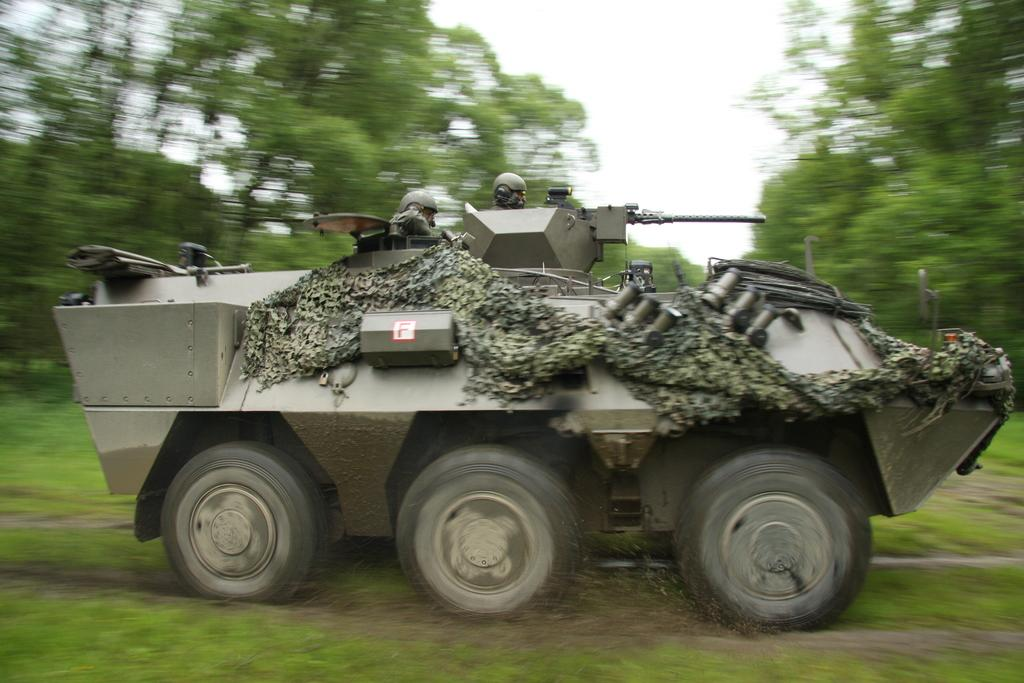What is the main subject of the image? There is a vehicle in the image. Who is inside the vehicle? There are people wearing helmets inside the vehicle. What type of environment is visible in the image? There is grass, trees, and the sky visible in the image. What type of tax is being discussed by the people inside the vehicle? There is no indication in the image that the people inside the vehicle are discussing any type of tax. Can you see a judge or a bell in the image? No, there is no judge or bell present in the image. 